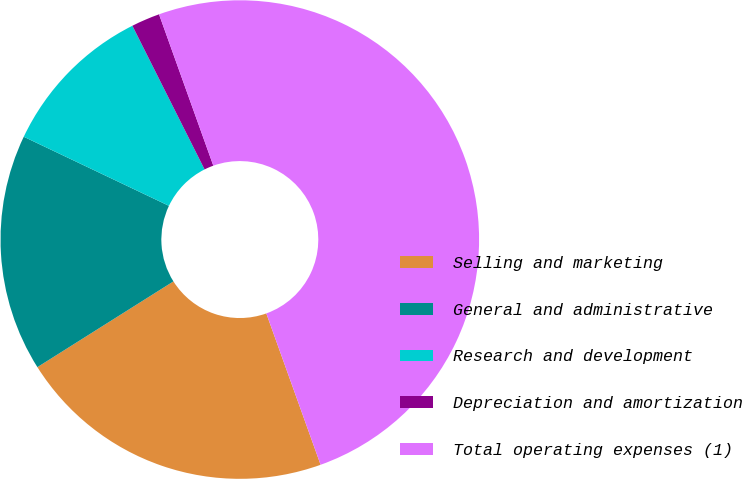Convert chart. <chart><loc_0><loc_0><loc_500><loc_500><pie_chart><fcel>Selling and marketing<fcel>General and administrative<fcel>Research and development<fcel>Depreciation and amortization<fcel>Total operating expenses (1)<nl><fcel>21.53%<fcel>16.02%<fcel>10.52%<fcel>1.93%<fcel>50.0%<nl></chart> 